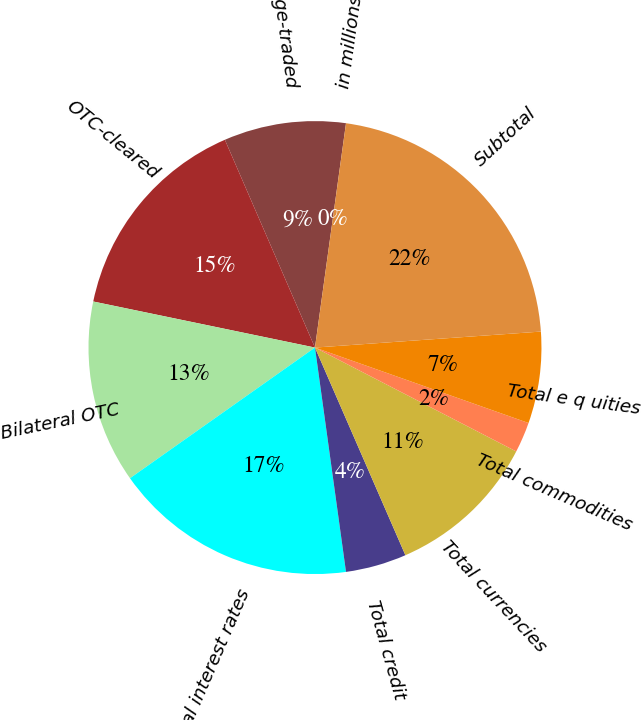<chart> <loc_0><loc_0><loc_500><loc_500><pie_chart><fcel>in millions<fcel>Exchange-traded<fcel>OTC-cleared<fcel>Bilateral OTC<fcel>Total interest rates<fcel>Total credit<fcel>Total currencies<fcel>Total commodities<fcel>Total e q uities<fcel>Subtotal<nl><fcel>0.0%<fcel>8.7%<fcel>15.23%<fcel>13.05%<fcel>17.4%<fcel>4.35%<fcel>10.88%<fcel>2.18%<fcel>6.53%<fcel>21.69%<nl></chart> 